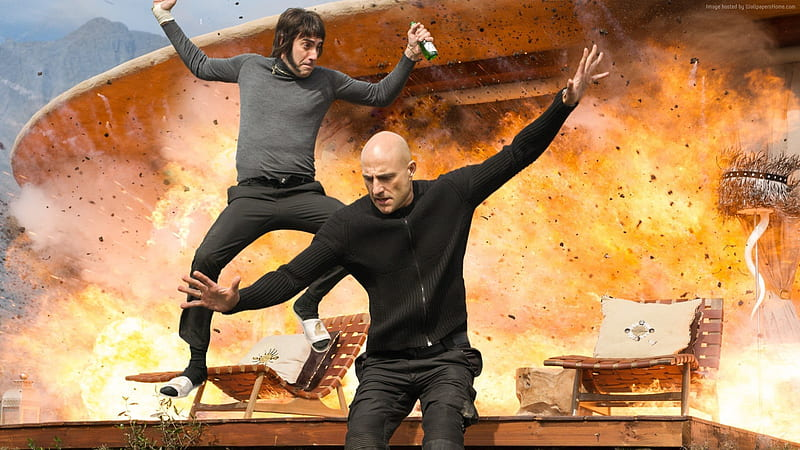What does the explosion in the background signify in this scene? The explosion adds a significant layer of drama and urgency, suggesting a high-stakes scenario possibly from an action film. It serves as a dynamic backdrop that emphasizes the perilous situation the characters find themselves in, possibly highlighting a climax or a critical turning point in a story. 